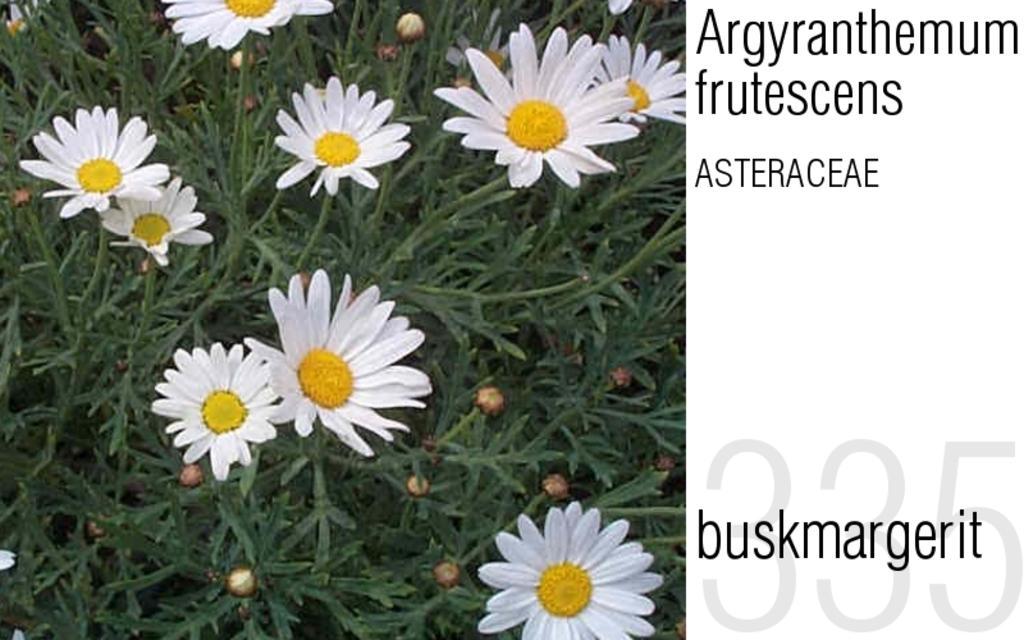Could you give a brief overview of what you see in this image? There are plants which has few white color flowers on it and there is something written beside it. 